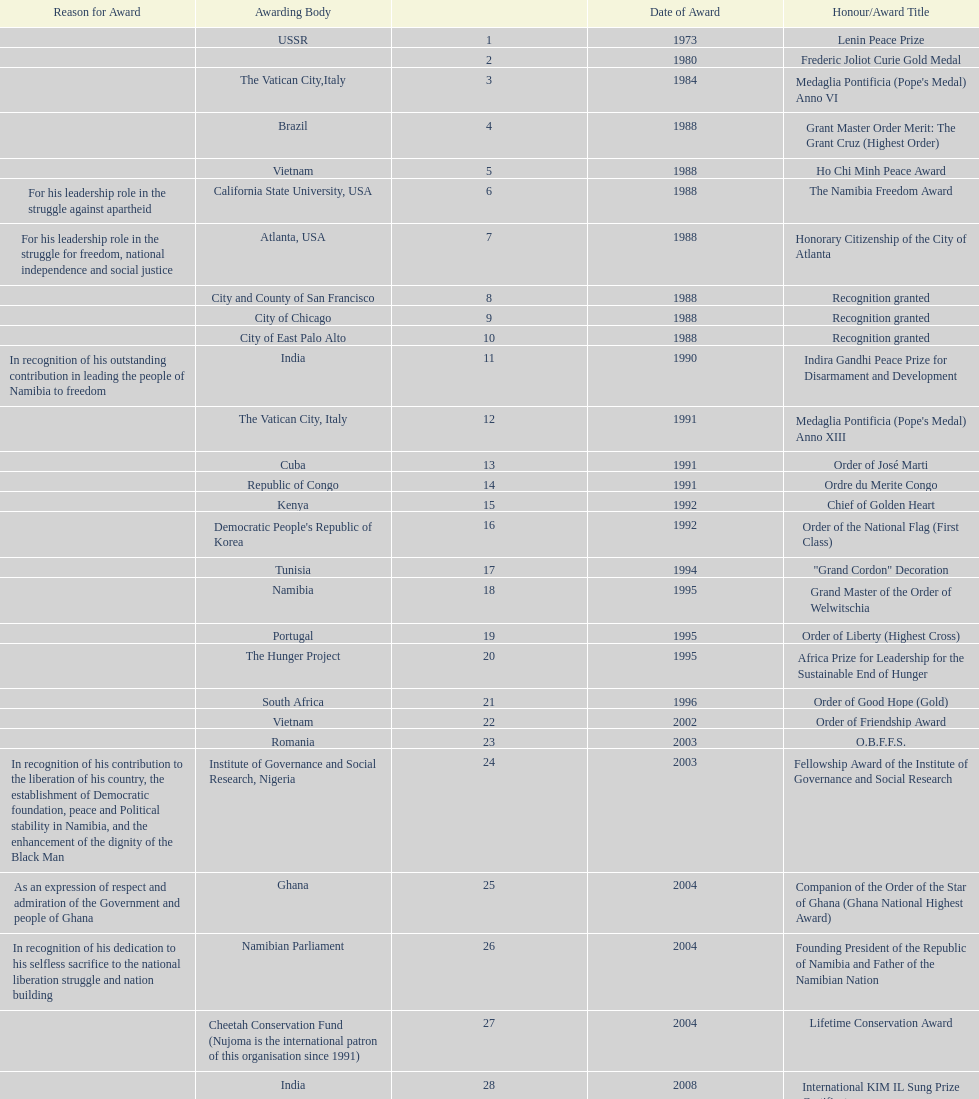Did nujoma win the o.b.f.f.s. award in romania or ghana? Romania. 